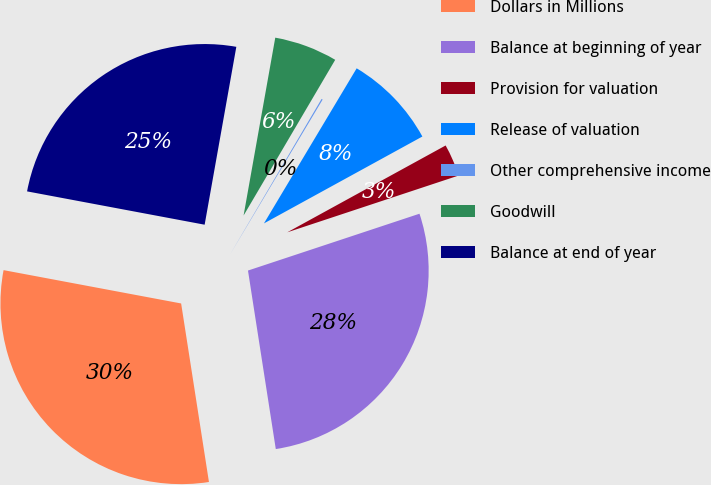<chart> <loc_0><loc_0><loc_500><loc_500><pie_chart><fcel>Dollars in Millions<fcel>Balance at beginning of year<fcel>Provision for valuation<fcel>Release of valuation<fcel>Other comprehensive income<fcel>Goodwill<fcel>Balance at end of year<nl><fcel>30.41%<fcel>27.63%<fcel>2.89%<fcel>8.44%<fcel>0.11%<fcel>5.66%<fcel>24.85%<nl></chart> 